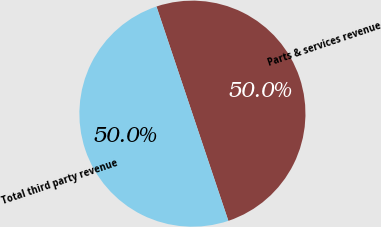Convert chart to OTSL. <chart><loc_0><loc_0><loc_500><loc_500><pie_chart><fcel>Parts & services revenue<fcel>Total third party revenue<nl><fcel>50.0%<fcel>50.0%<nl></chart> 